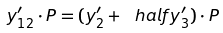<formula> <loc_0><loc_0><loc_500><loc_500>y ^ { \prime } _ { 1 2 } \cdot P = ( y ^ { \prime } _ { 2 } + \ h a l f y ^ { \prime } _ { 3 } ) \cdot P</formula> 